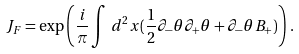Convert formula to latex. <formula><loc_0><loc_0><loc_500><loc_500>J _ { F } = \exp \left ( \frac { i } { \pi } \int \, d ^ { 2 } x ( \frac { 1 } { 2 } \partial _ { - } \theta \partial _ { + } \theta + \partial _ { - } \theta B _ { + } ) \right ) \, .</formula> 